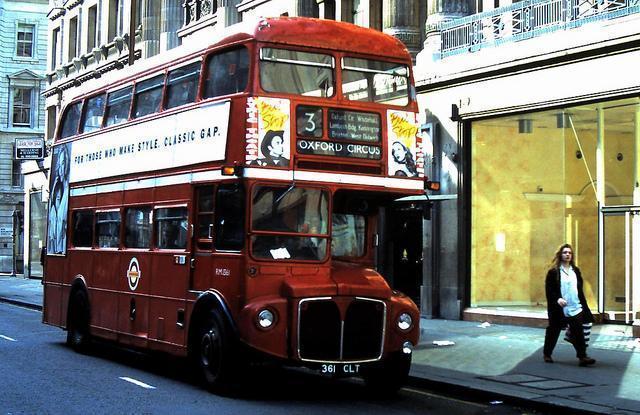What is one of the stops for this bus?
Answer the question by selecting the correct answer among the 4 following choices.
Options: Dublin, edinburgh, oxford circus, victoria station. Oxford circus. 